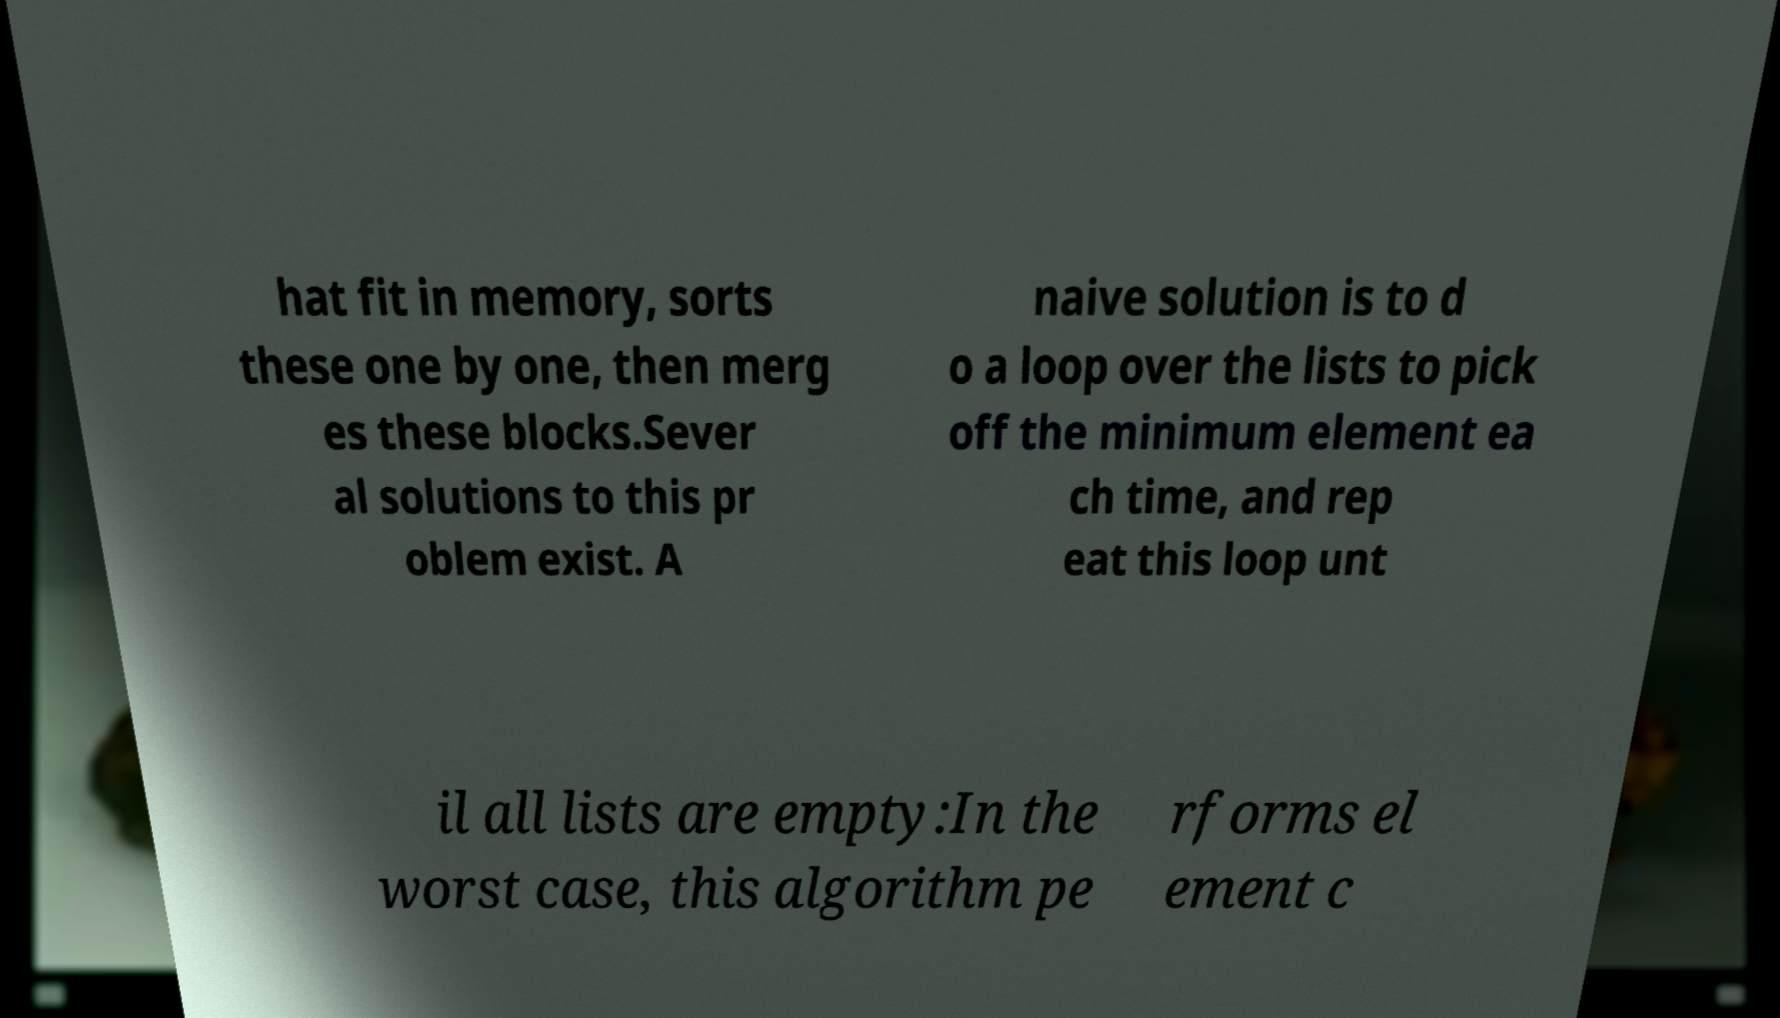For documentation purposes, I need the text within this image transcribed. Could you provide that? hat fit in memory, sorts these one by one, then merg es these blocks.Sever al solutions to this pr oblem exist. A naive solution is to d o a loop over the lists to pick off the minimum element ea ch time, and rep eat this loop unt il all lists are empty:In the worst case, this algorithm pe rforms el ement c 